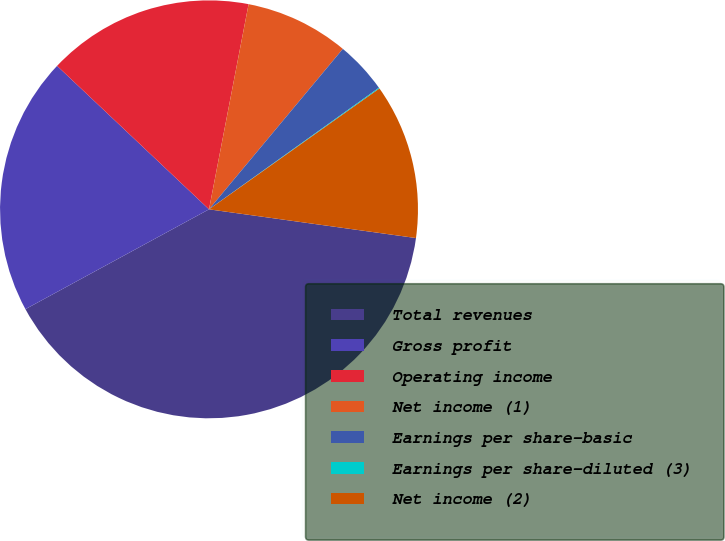Convert chart. <chart><loc_0><loc_0><loc_500><loc_500><pie_chart><fcel>Total revenues<fcel>Gross profit<fcel>Operating income<fcel>Net income (1)<fcel>Earnings per share-basic<fcel>Earnings per share-diluted (3)<fcel>Net income (2)<nl><fcel>39.88%<fcel>19.97%<fcel>15.99%<fcel>8.03%<fcel>4.05%<fcel>0.07%<fcel>12.01%<nl></chart> 